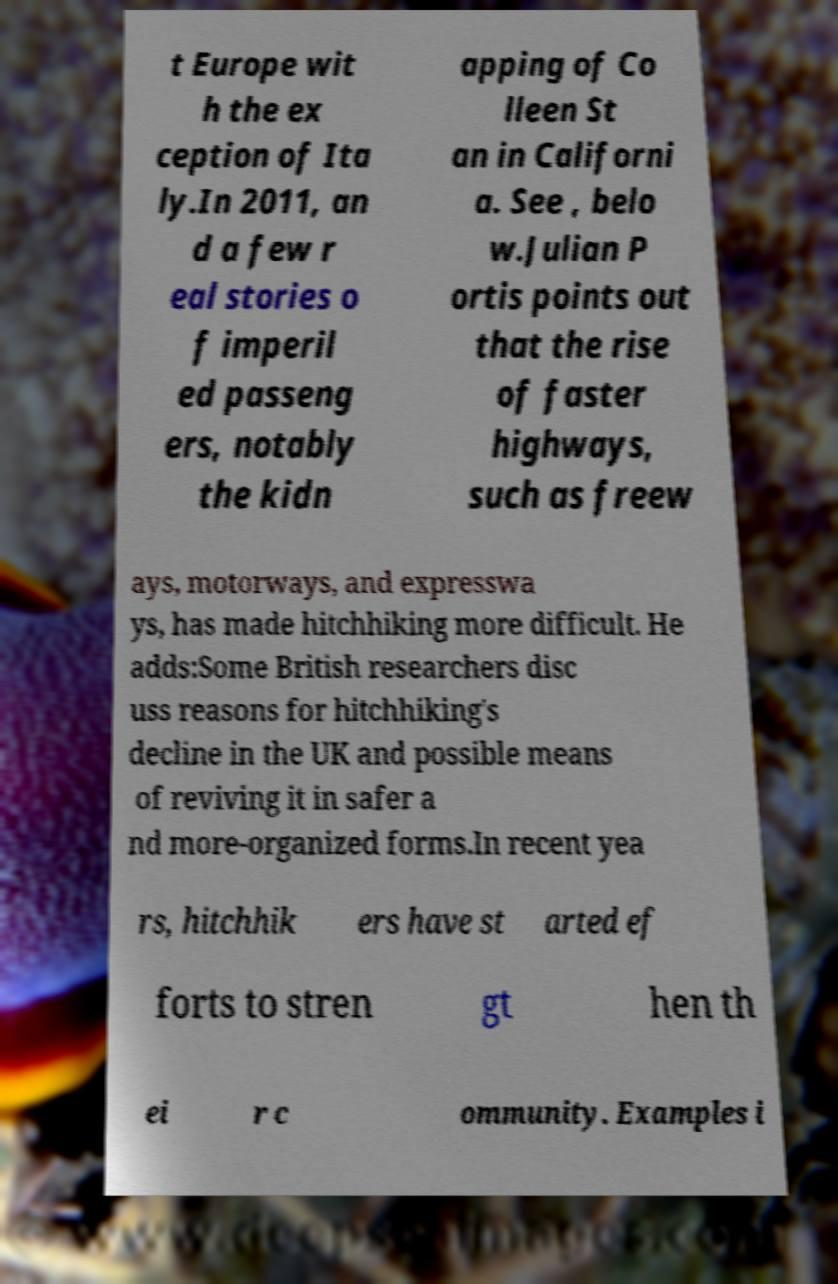Please read and relay the text visible in this image. What does it say? t Europe wit h the ex ception of Ita ly.In 2011, an d a few r eal stories o f imperil ed passeng ers, notably the kidn apping of Co lleen St an in Californi a. See , belo w.Julian P ortis points out that the rise of faster highways, such as freew ays, motorways, and expresswa ys, has made hitchhiking more difficult. He adds:Some British researchers disc uss reasons for hitchhiking's decline in the UK and possible means of reviving it in safer a nd more-organized forms.In recent yea rs, hitchhik ers have st arted ef forts to stren gt hen th ei r c ommunity. Examples i 